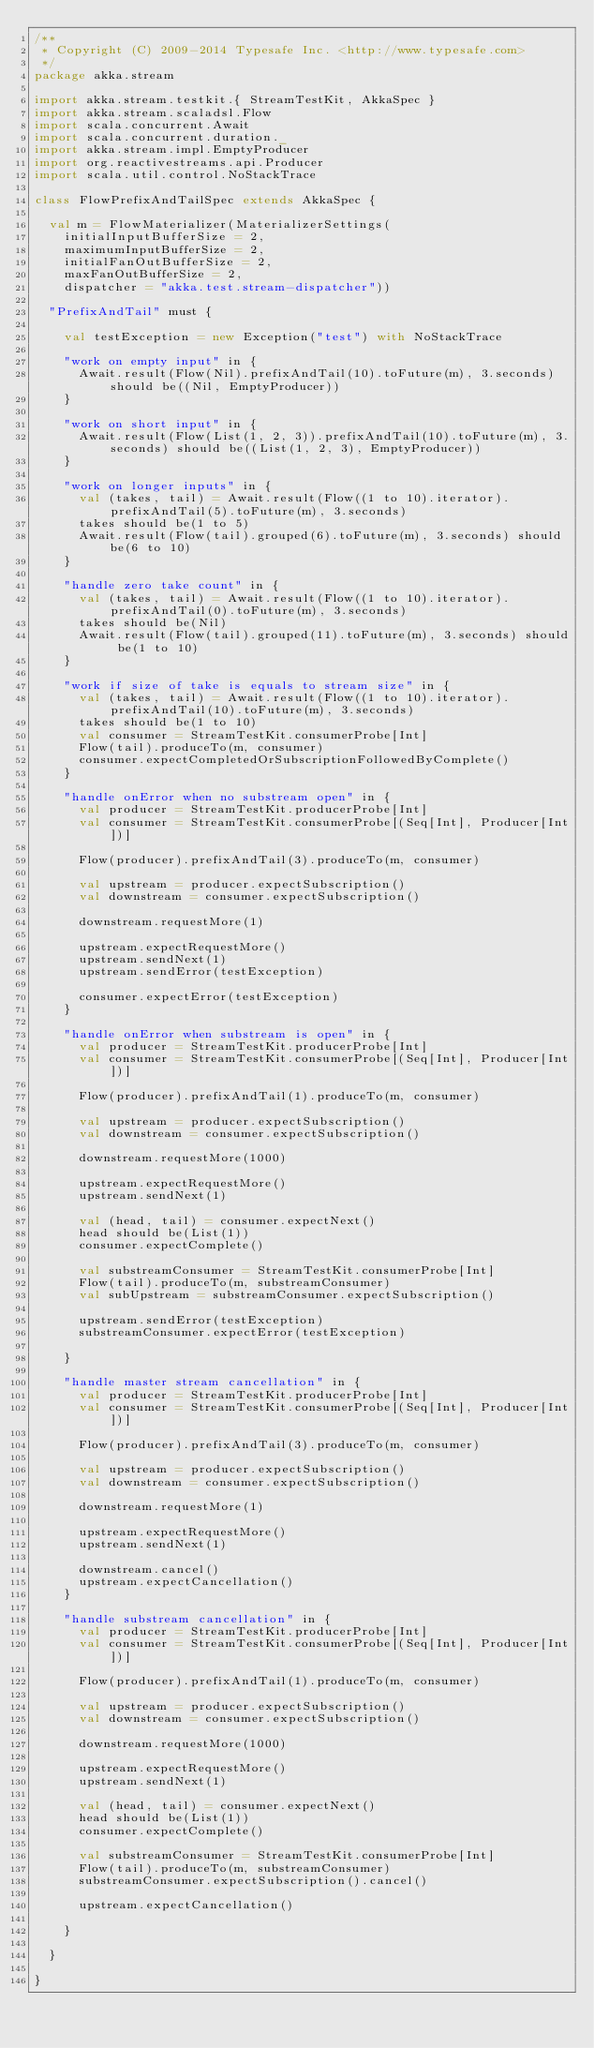<code> <loc_0><loc_0><loc_500><loc_500><_Scala_>/**
 * Copyright (C) 2009-2014 Typesafe Inc. <http://www.typesafe.com>
 */
package akka.stream

import akka.stream.testkit.{ StreamTestKit, AkkaSpec }
import akka.stream.scaladsl.Flow
import scala.concurrent.Await
import scala.concurrent.duration._
import akka.stream.impl.EmptyProducer
import org.reactivestreams.api.Producer
import scala.util.control.NoStackTrace

class FlowPrefixAndTailSpec extends AkkaSpec {

  val m = FlowMaterializer(MaterializerSettings(
    initialInputBufferSize = 2,
    maximumInputBufferSize = 2,
    initialFanOutBufferSize = 2,
    maxFanOutBufferSize = 2,
    dispatcher = "akka.test.stream-dispatcher"))

  "PrefixAndTail" must {

    val testException = new Exception("test") with NoStackTrace

    "work on empty input" in {
      Await.result(Flow(Nil).prefixAndTail(10).toFuture(m), 3.seconds) should be((Nil, EmptyProducer))
    }

    "work on short input" in {
      Await.result(Flow(List(1, 2, 3)).prefixAndTail(10).toFuture(m), 3.seconds) should be((List(1, 2, 3), EmptyProducer))
    }

    "work on longer inputs" in {
      val (takes, tail) = Await.result(Flow((1 to 10).iterator).prefixAndTail(5).toFuture(m), 3.seconds)
      takes should be(1 to 5)
      Await.result(Flow(tail).grouped(6).toFuture(m), 3.seconds) should be(6 to 10)
    }

    "handle zero take count" in {
      val (takes, tail) = Await.result(Flow((1 to 10).iterator).prefixAndTail(0).toFuture(m), 3.seconds)
      takes should be(Nil)
      Await.result(Flow(tail).grouped(11).toFuture(m), 3.seconds) should be(1 to 10)
    }

    "work if size of take is equals to stream size" in {
      val (takes, tail) = Await.result(Flow((1 to 10).iterator).prefixAndTail(10).toFuture(m), 3.seconds)
      takes should be(1 to 10)
      val consumer = StreamTestKit.consumerProbe[Int]
      Flow(tail).produceTo(m, consumer)
      consumer.expectCompletedOrSubscriptionFollowedByComplete()
    }

    "handle onError when no substream open" in {
      val producer = StreamTestKit.producerProbe[Int]
      val consumer = StreamTestKit.consumerProbe[(Seq[Int], Producer[Int])]

      Flow(producer).prefixAndTail(3).produceTo(m, consumer)

      val upstream = producer.expectSubscription()
      val downstream = consumer.expectSubscription()

      downstream.requestMore(1)

      upstream.expectRequestMore()
      upstream.sendNext(1)
      upstream.sendError(testException)

      consumer.expectError(testException)
    }

    "handle onError when substream is open" in {
      val producer = StreamTestKit.producerProbe[Int]
      val consumer = StreamTestKit.consumerProbe[(Seq[Int], Producer[Int])]

      Flow(producer).prefixAndTail(1).produceTo(m, consumer)

      val upstream = producer.expectSubscription()
      val downstream = consumer.expectSubscription()

      downstream.requestMore(1000)

      upstream.expectRequestMore()
      upstream.sendNext(1)

      val (head, tail) = consumer.expectNext()
      head should be(List(1))
      consumer.expectComplete()

      val substreamConsumer = StreamTestKit.consumerProbe[Int]
      Flow(tail).produceTo(m, substreamConsumer)
      val subUpstream = substreamConsumer.expectSubscription()

      upstream.sendError(testException)
      substreamConsumer.expectError(testException)

    }

    "handle master stream cancellation" in {
      val producer = StreamTestKit.producerProbe[Int]
      val consumer = StreamTestKit.consumerProbe[(Seq[Int], Producer[Int])]

      Flow(producer).prefixAndTail(3).produceTo(m, consumer)

      val upstream = producer.expectSubscription()
      val downstream = consumer.expectSubscription()

      downstream.requestMore(1)

      upstream.expectRequestMore()
      upstream.sendNext(1)

      downstream.cancel()
      upstream.expectCancellation()
    }

    "handle substream cancellation" in {
      val producer = StreamTestKit.producerProbe[Int]
      val consumer = StreamTestKit.consumerProbe[(Seq[Int], Producer[Int])]

      Flow(producer).prefixAndTail(1).produceTo(m, consumer)

      val upstream = producer.expectSubscription()
      val downstream = consumer.expectSubscription()

      downstream.requestMore(1000)

      upstream.expectRequestMore()
      upstream.sendNext(1)

      val (head, tail) = consumer.expectNext()
      head should be(List(1))
      consumer.expectComplete()

      val substreamConsumer = StreamTestKit.consumerProbe[Int]
      Flow(tail).produceTo(m, substreamConsumer)
      substreamConsumer.expectSubscription().cancel()

      upstream.expectCancellation()

    }

  }

}
</code> 